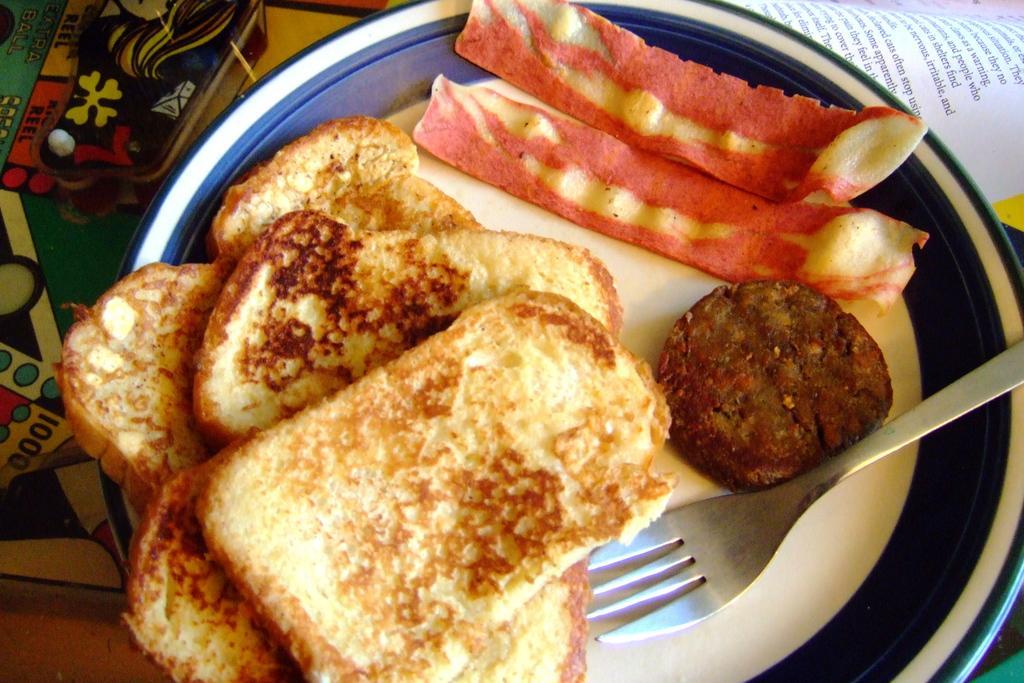In one or two sentences, can you explain what this image depicts? In this image there is an object truncated towards the left of the image, there is a plate truncated towards the bottom of the image, there is food on the plate, there is food truncated towards the bottom of the image, there is a fork truncated towards the right of the image, there is a paper truncated towards the top of the image, there is text on the paper. 